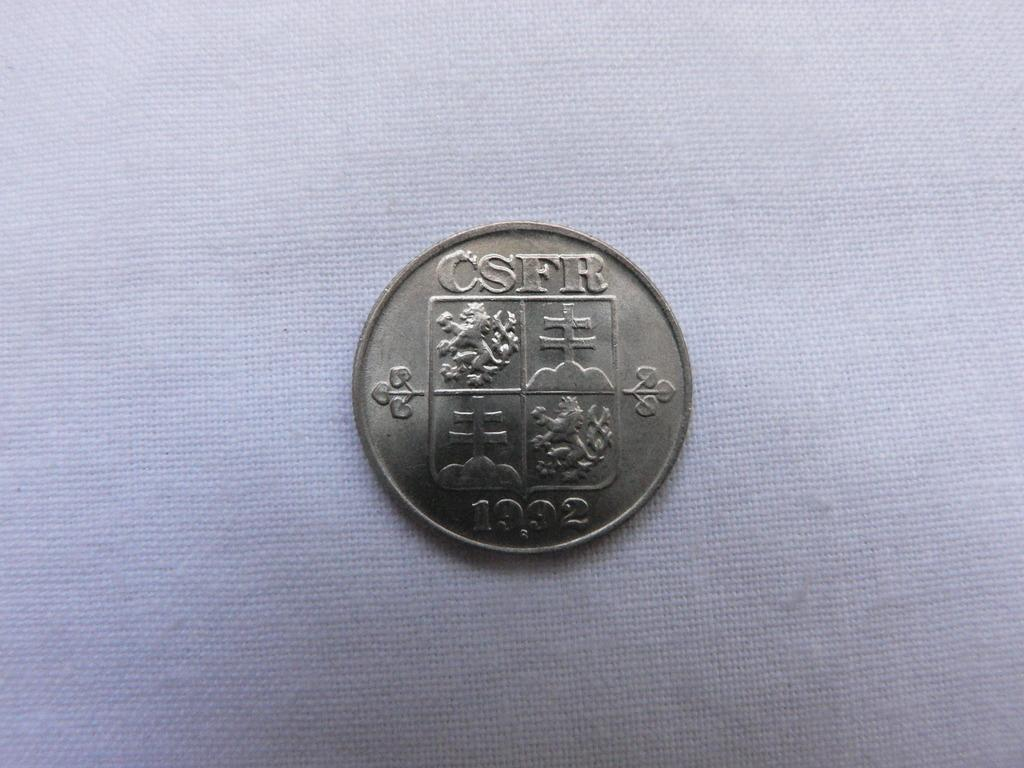What object is located in the center of the image? There is a coin in the center of the image. Can you describe the coin in the image? The coin is the main object in the image, and it is located in the center. How many rings are visible on the coin in the image? There are no rings visible on the coin in the image. What type of attention is the coin receiving in the image? The image does not depict the coin receiving any specific type of attention. 